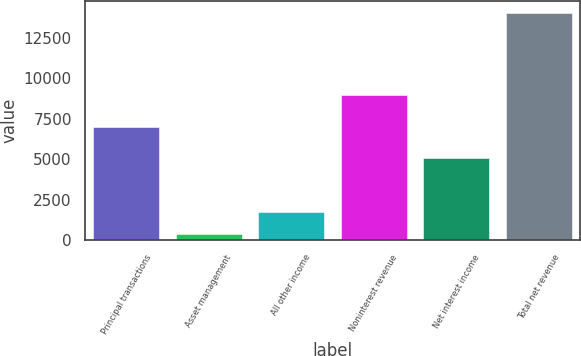Convert chart to OTSL. <chart><loc_0><loc_0><loc_500><loc_500><bar_chart><fcel>Principal transactions<fcel>Asset management<fcel>All other income<fcel>Noninterest revenue<fcel>Net interest income<fcel>Total net revenue<nl><fcel>7014<fcel>345<fcel>1718<fcel>8980<fcel>5095<fcel>14075<nl></chart> 